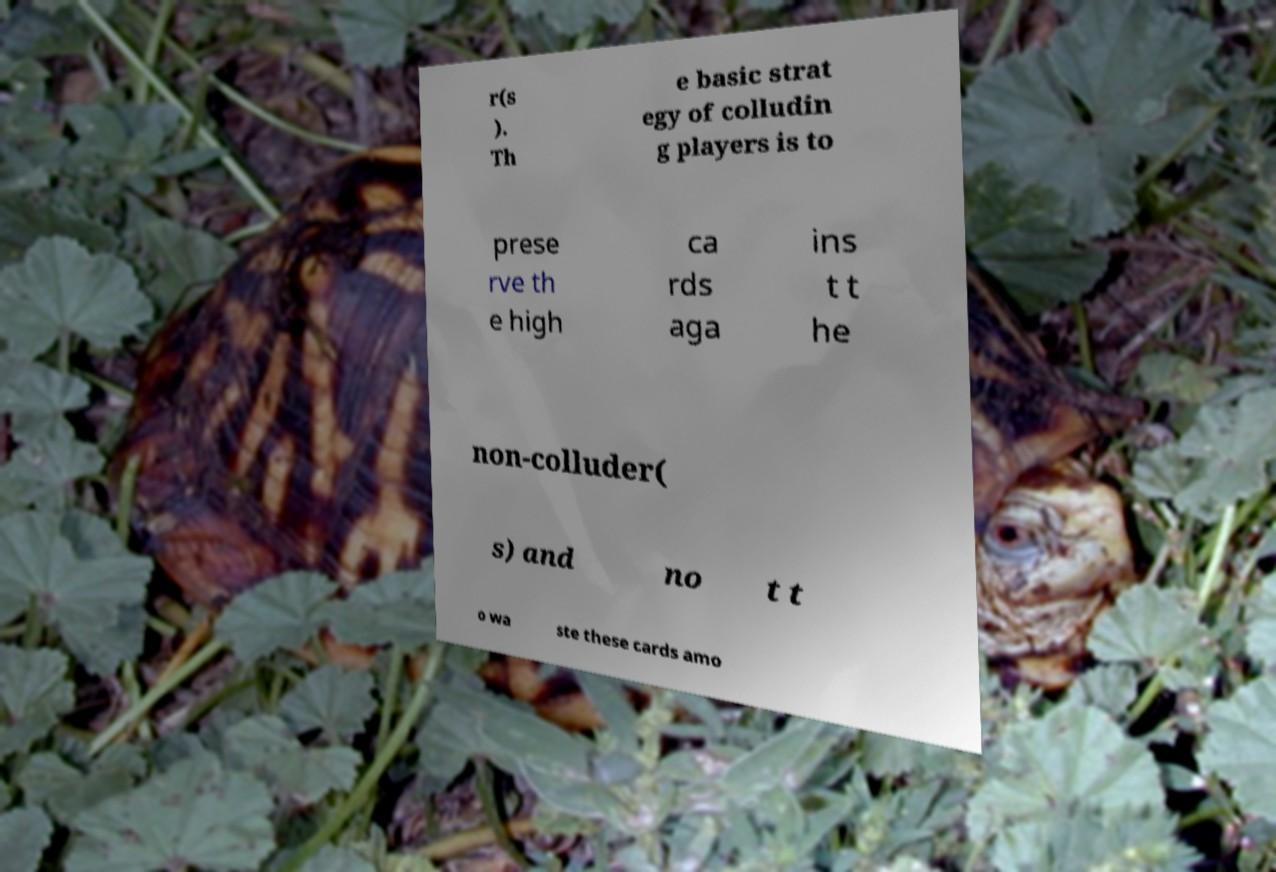I need the written content from this picture converted into text. Can you do that? r(s ). Th e basic strat egy of colludin g players is to prese rve th e high ca rds aga ins t t he non-colluder( s) and no t t o wa ste these cards amo 